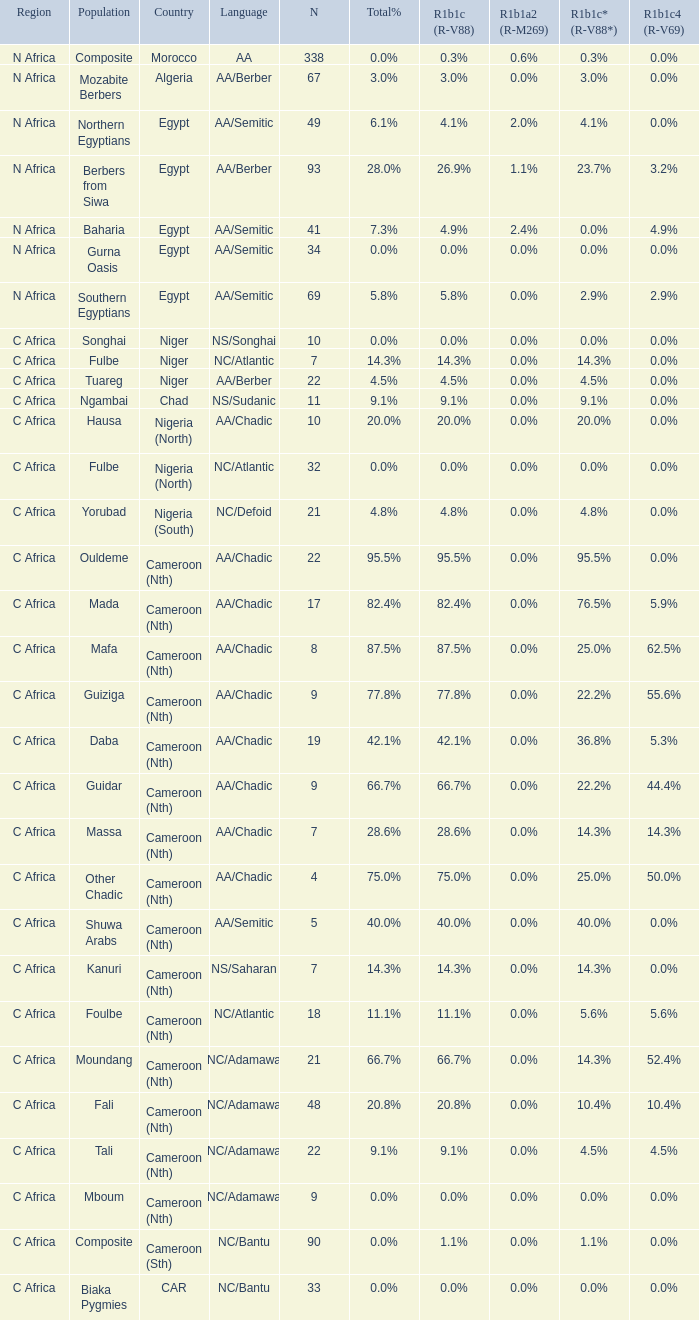How many n are listed for 0.6% r1b1a2 (r-m269)? 1.0. 